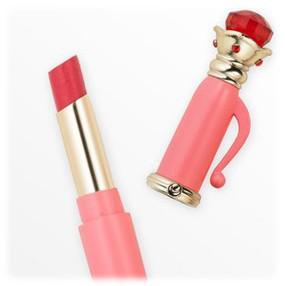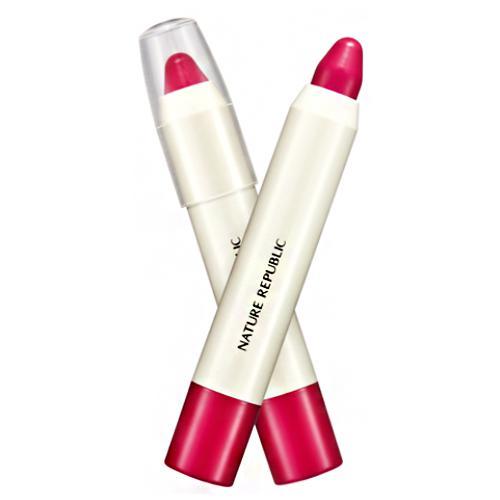The first image is the image on the left, the second image is the image on the right. Given the left and right images, does the statement "In one of the photos, there are two sticks of lipstick crossing each other." hold true? Answer yes or no. Yes. The first image is the image on the left, the second image is the image on the right. Given the left and right images, does the statement "There are 2 lipstick pencils crossed neatly like an X and one has the cap off." hold true? Answer yes or no. Yes. 